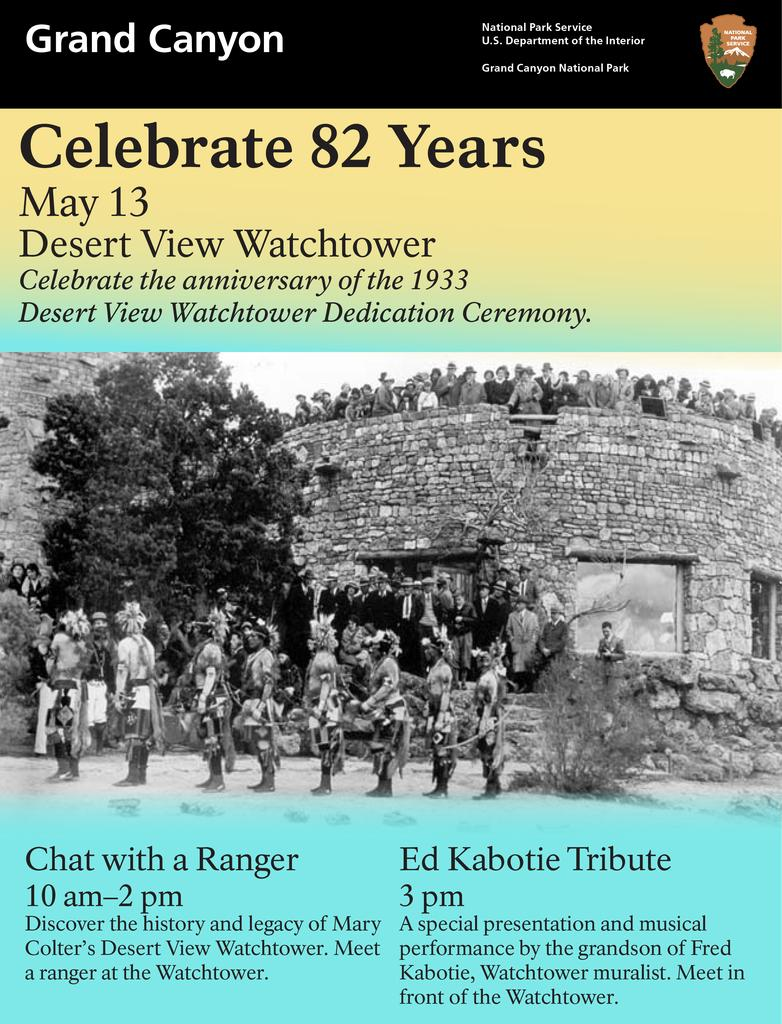<image>
Relay a brief, clear account of the picture shown. A poster for the Grand Canyon and its watchtower. 